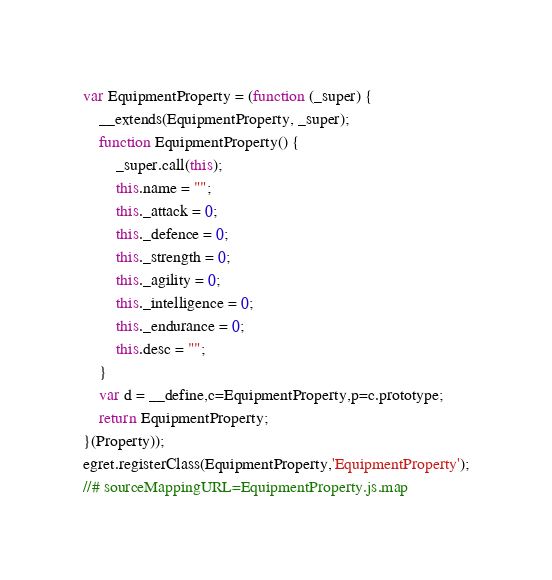Convert code to text. <code><loc_0><loc_0><loc_500><loc_500><_JavaScript_>var EquipmentProperty = (function (_super) {
    __extends(EquipmentProperty, _super);
    function EquipmentProperty() {
        _super.call(this);
        this.name = "";
        this._attack = 0;
        this._defence = 0;
        this._strength = 0;
        this._agility = 0;
        this._intelligence = 0;
        this._endurance = 0;
        this.desc = "";
    }
    var d = __define,c=EquipmentProperty,p=c.prototype;
    return EquipmentProperty;
}(Property));
egret.registerClass(EquipmentProperty,'EquipmentProperty');
//# sourceMappingURL=EquipmentProperty.js.map</code> 